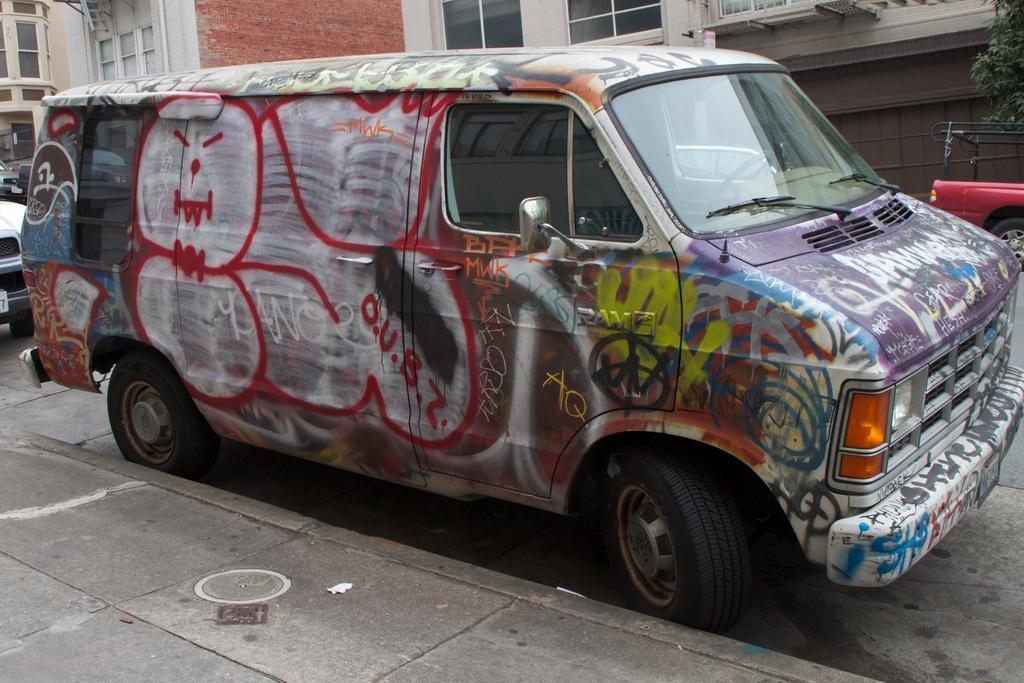Please provide a concise description of this image. In this picture we can see vehicles on the road. Behind the vehicles, there are buildings. In the top right corner of the image, there is a tree. At the bottom of the image, it looks like a manhole lid on the walkway. 